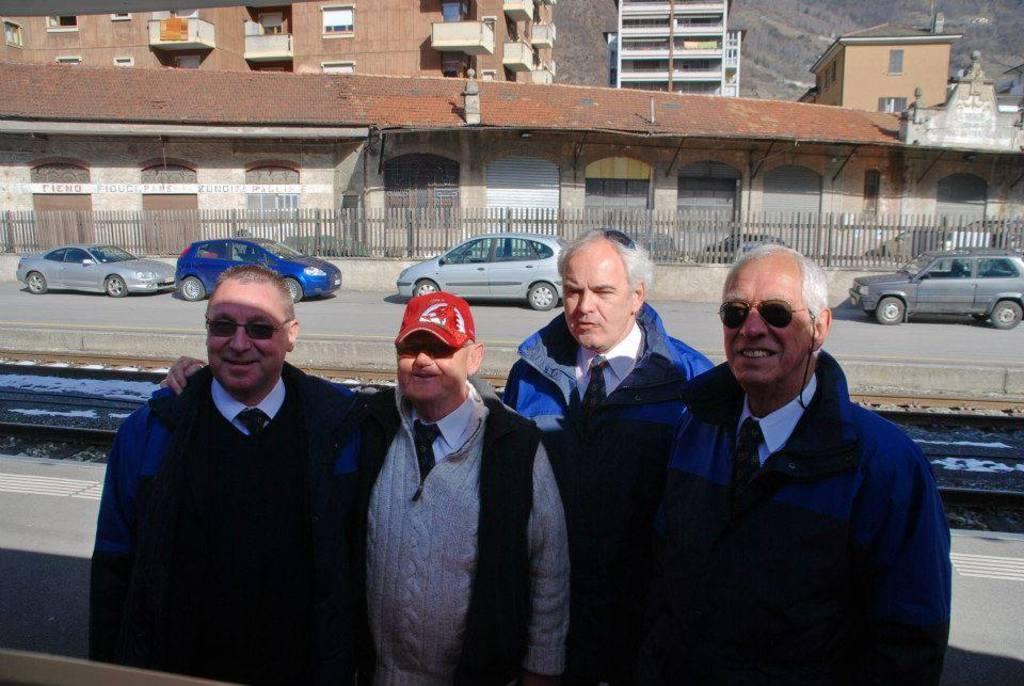How would you summarize this image in a sentence or two? In this picture there are four men were standing near to the road. In the back we can see the railway tracks, beside that we can see many cars which is parked near to the fencing. Beside that we can see the buildings. In the top right corner we can see the mountains and trees. On the left we can see many doors and windows. 